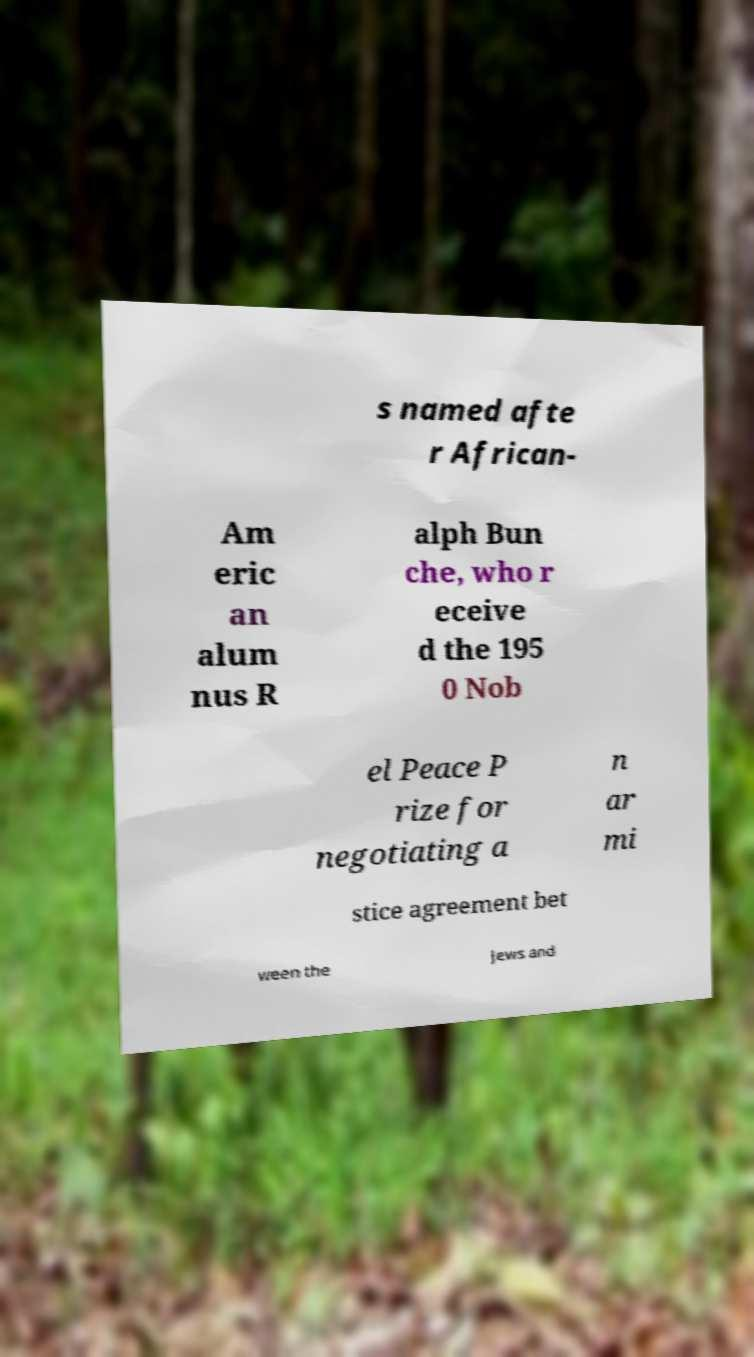I need the written content from this picture converted into text. Can you do that? s named afte r African- Am eric an alum nus R alph Bun che, who r eceive d the 195 0 Nob el Peace P rize for negotiating a n ar mi stice agreement bet ween the Jews and 